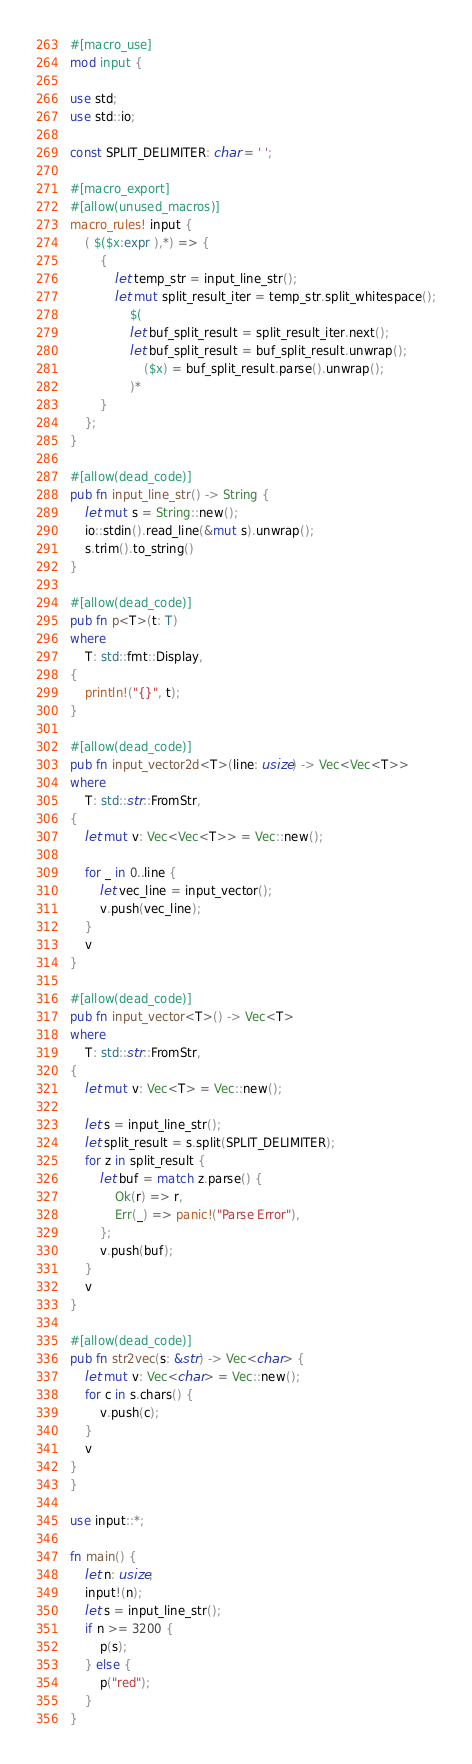Convert code to text. <code><loc_0><loc_0><loc_500><loc_500><_Rust_>#[macro_use]
mod input {

use std;
use std::io;

const SPLIT_DELIMITER: char = ' ';

#[macro_export]
#[allow(unused_macros)]
macro_rules! input {
    ( $($x:expr ),*) => {
        {
            let temp_str = input_line_str();
            let mut split_result_iter = temp_str.split_whitespace();
                $(
                let buf_split_result = split_result_iter.next();
                let buf_split_result = buf_split_result.unwrap();
                    ($x) = buf_split_result.parse().unwrap();
                )*
        }
    };
}

#[allow(dead_code)]
pub fn input_line_str() -> String {
    let mut s = String::new();
    io::stdin().read_line(&mut s).unwrap();
    s.trim().to_string()
}

#[allow(dead_code)]
pub fn p<T>(t: T)
where
    T: std::fmt::Display,
{
    println!("{}", t);
}

#[allow(dead_code)]
pub fn input_vector2d<T>(line: usize) -> Vec<Vec<T>>
where
    T: std::str::FromStr,
{
    let mut v: Vec<Vec<T>> = Vec::new();

    for _ in 0..line {
        let vec_line = input_vector();
        v.push(vec_line);
    }
    v
}

#[allow(dead_code)]
pub fn input_vector<T>() -> Vec<T>
where
    T: std::str::FromStr,
{
    let mut v: Vec<T> = Vec::new();

    let s = input_line_str();
    let split_result = s.split(SPLIT_DELIMITER);
    for z in split_result {
        let buf = match z.parse() {
            Ok(r) => r,
            Err(_) => panic!("Parse Error"),
        };
        v.push(buf);
    }
    v
}

#[allow(dead_code)]
pub fn str2vec(s: &str) -> Vec<char> {
    let mut v: Vec<char> = Vec::new();
    for c in s.chars() {
        v.push(c);
    }
    v
}
}

use input::*;

fn main() {
    let n: usize;
    input!(n);
    let s = input_line_str();
    if n >= 3200 {
        p(s);
    } else {
        p("red");
    }
}</code> 